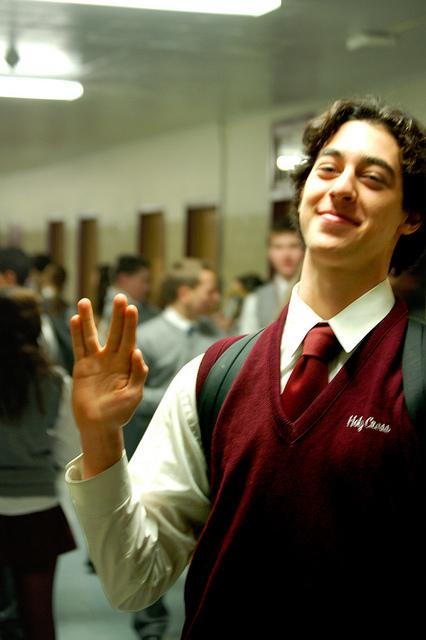What school does this boy attend? holy cross 